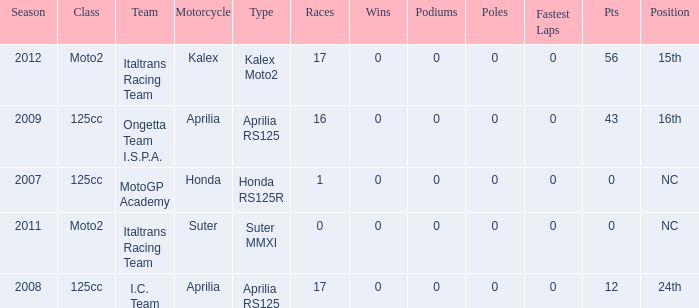What's the number of poles in the season where the team had a Kalex motorcycle? 0.0. 